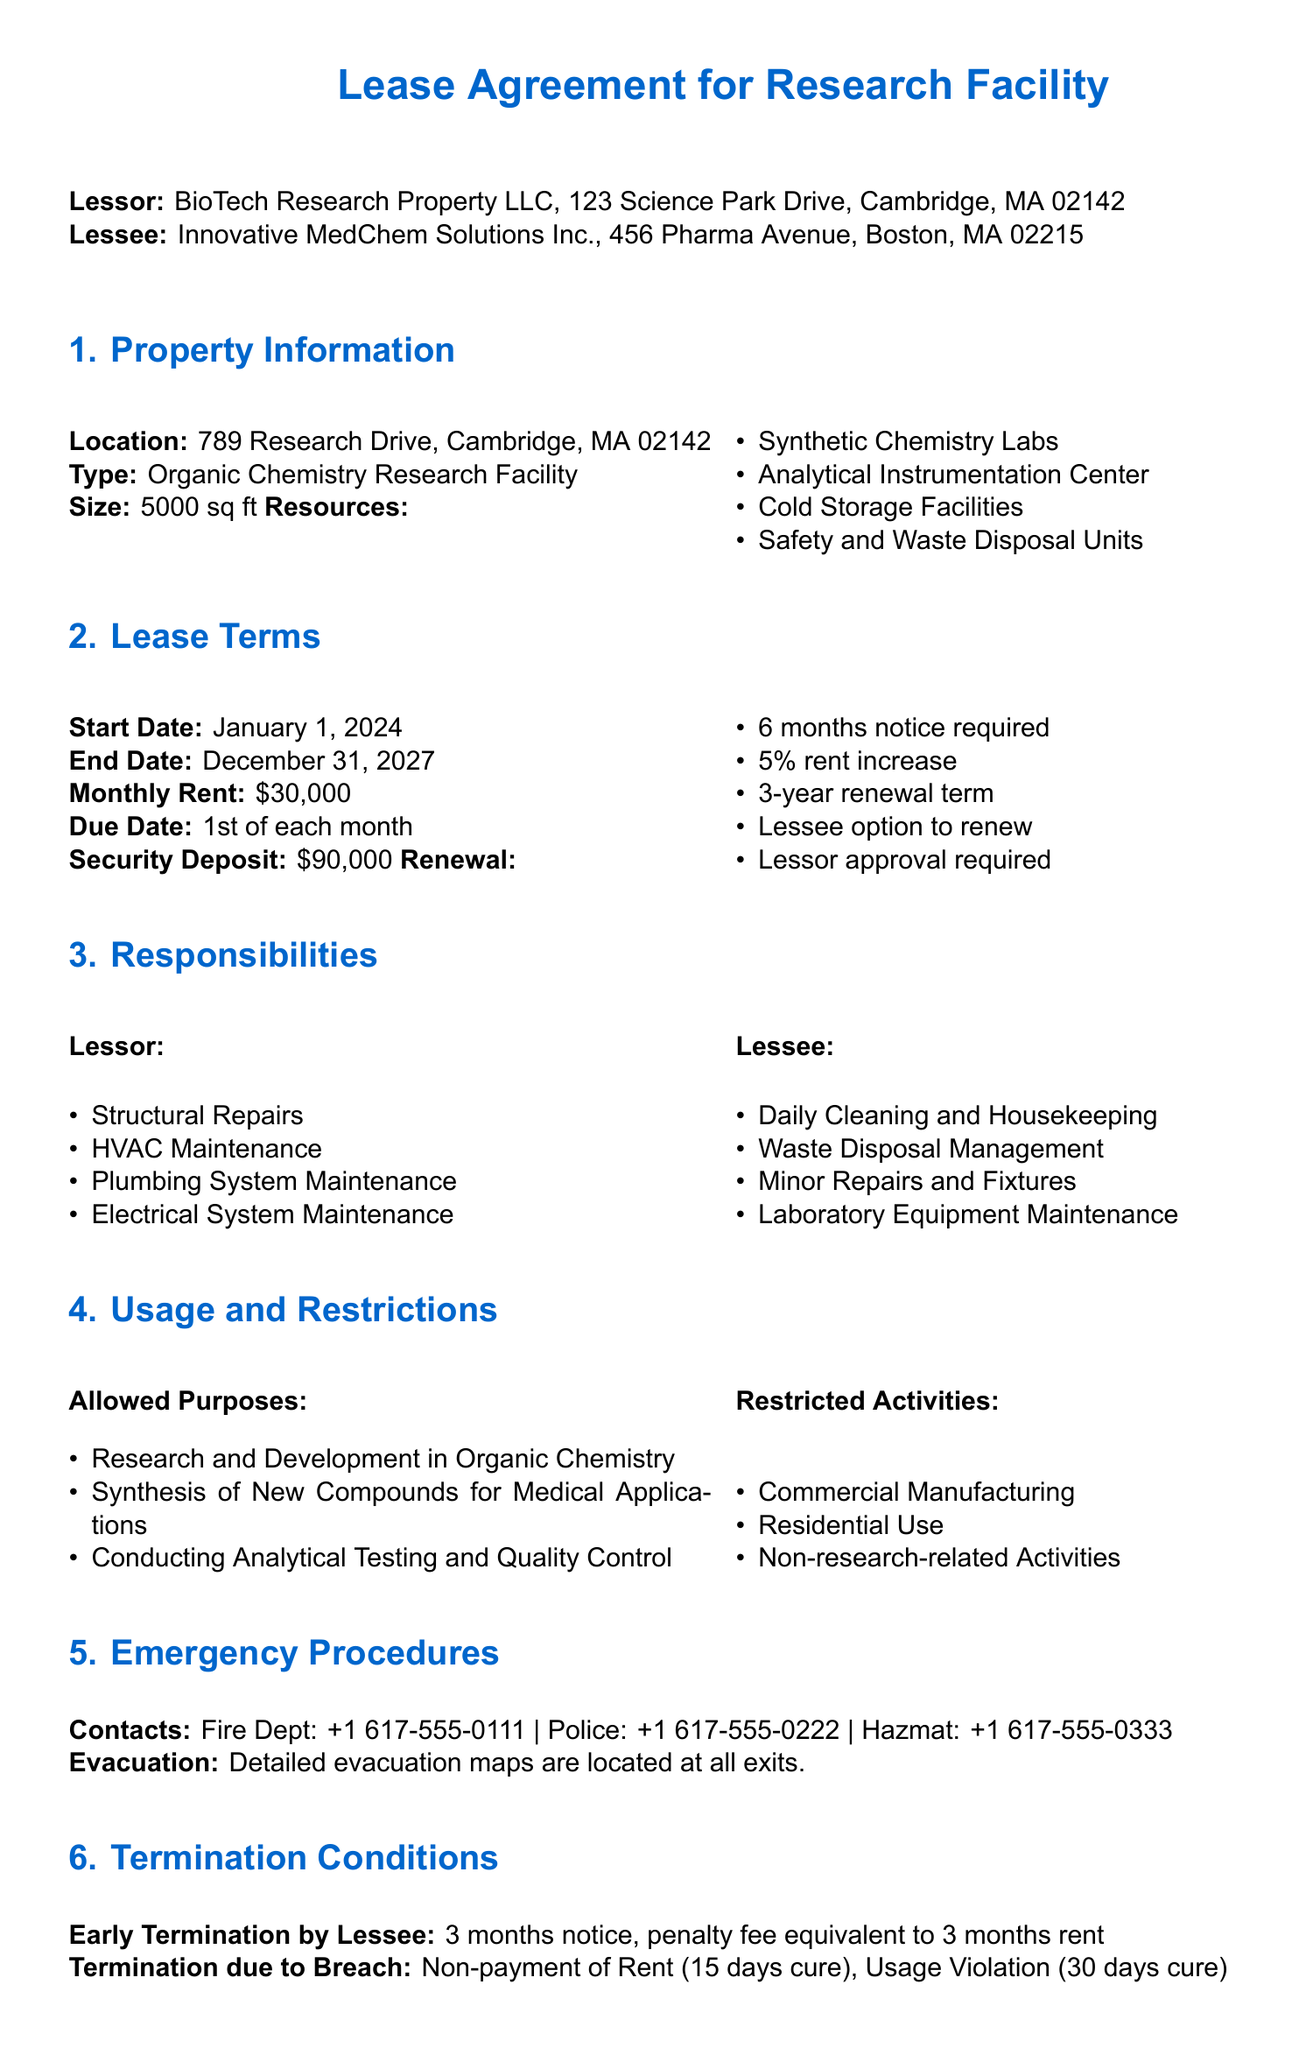What is the type of facility being leased? The document specifies that the property type is an Organic Chemistry Research Facility.
Answer: Organic Chemistry Research Facility What is the start date of the lease? The lease agreement states that the lease starts on January 1, 2024.
Answer: January 1, 2024 What is the monthly rent amount? The specified monthly rent in the document is $30,000.
Answer: $30,000 How much notice is required for renewal? The lease requires a 6 months notice for renewal.
Answer: 6 months What is the security deposit amount? According to the lease, the security deposit is $90,000.
Answer: $90,000 What is the penalty for early termination by the lessee? The agreement states that the penalty fee for early termination is equivalent to 3 months rent.
Answer: 3 months rent What is the renewal rent increase percentage? The document indicates that there is a 5% rent increase upon renewal.
Answer: 5% How long is the renewal term for the lease? The lease allows for a 3-year renewal term.
Answer: 3 years What responsibilities does the lessee have regarding laboratory equipment? The lessee is responsible for laboratory equipment maintenance as outlined in the lease.
Answer: Laboratory Equipment Maintenance 